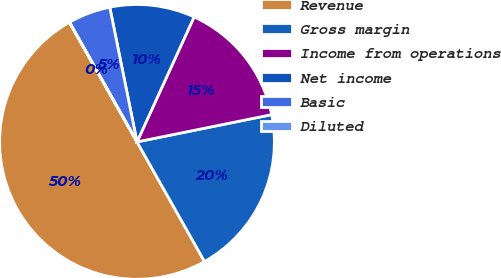Convert chart. <chart><loc_0><loc_0><loc_500><loc_500><pie_chart><fcel>Revenue<fcel>Gross margin<fcel>Income from operations<fcel>Net income<fcel>Basic<fcel>Diluted<nl><fcel>49.99%<fcel>20.0%<fcel>15.0%<fcel>10.0%<fcel>5.0%<fcel>0.01%<nl></chart> 